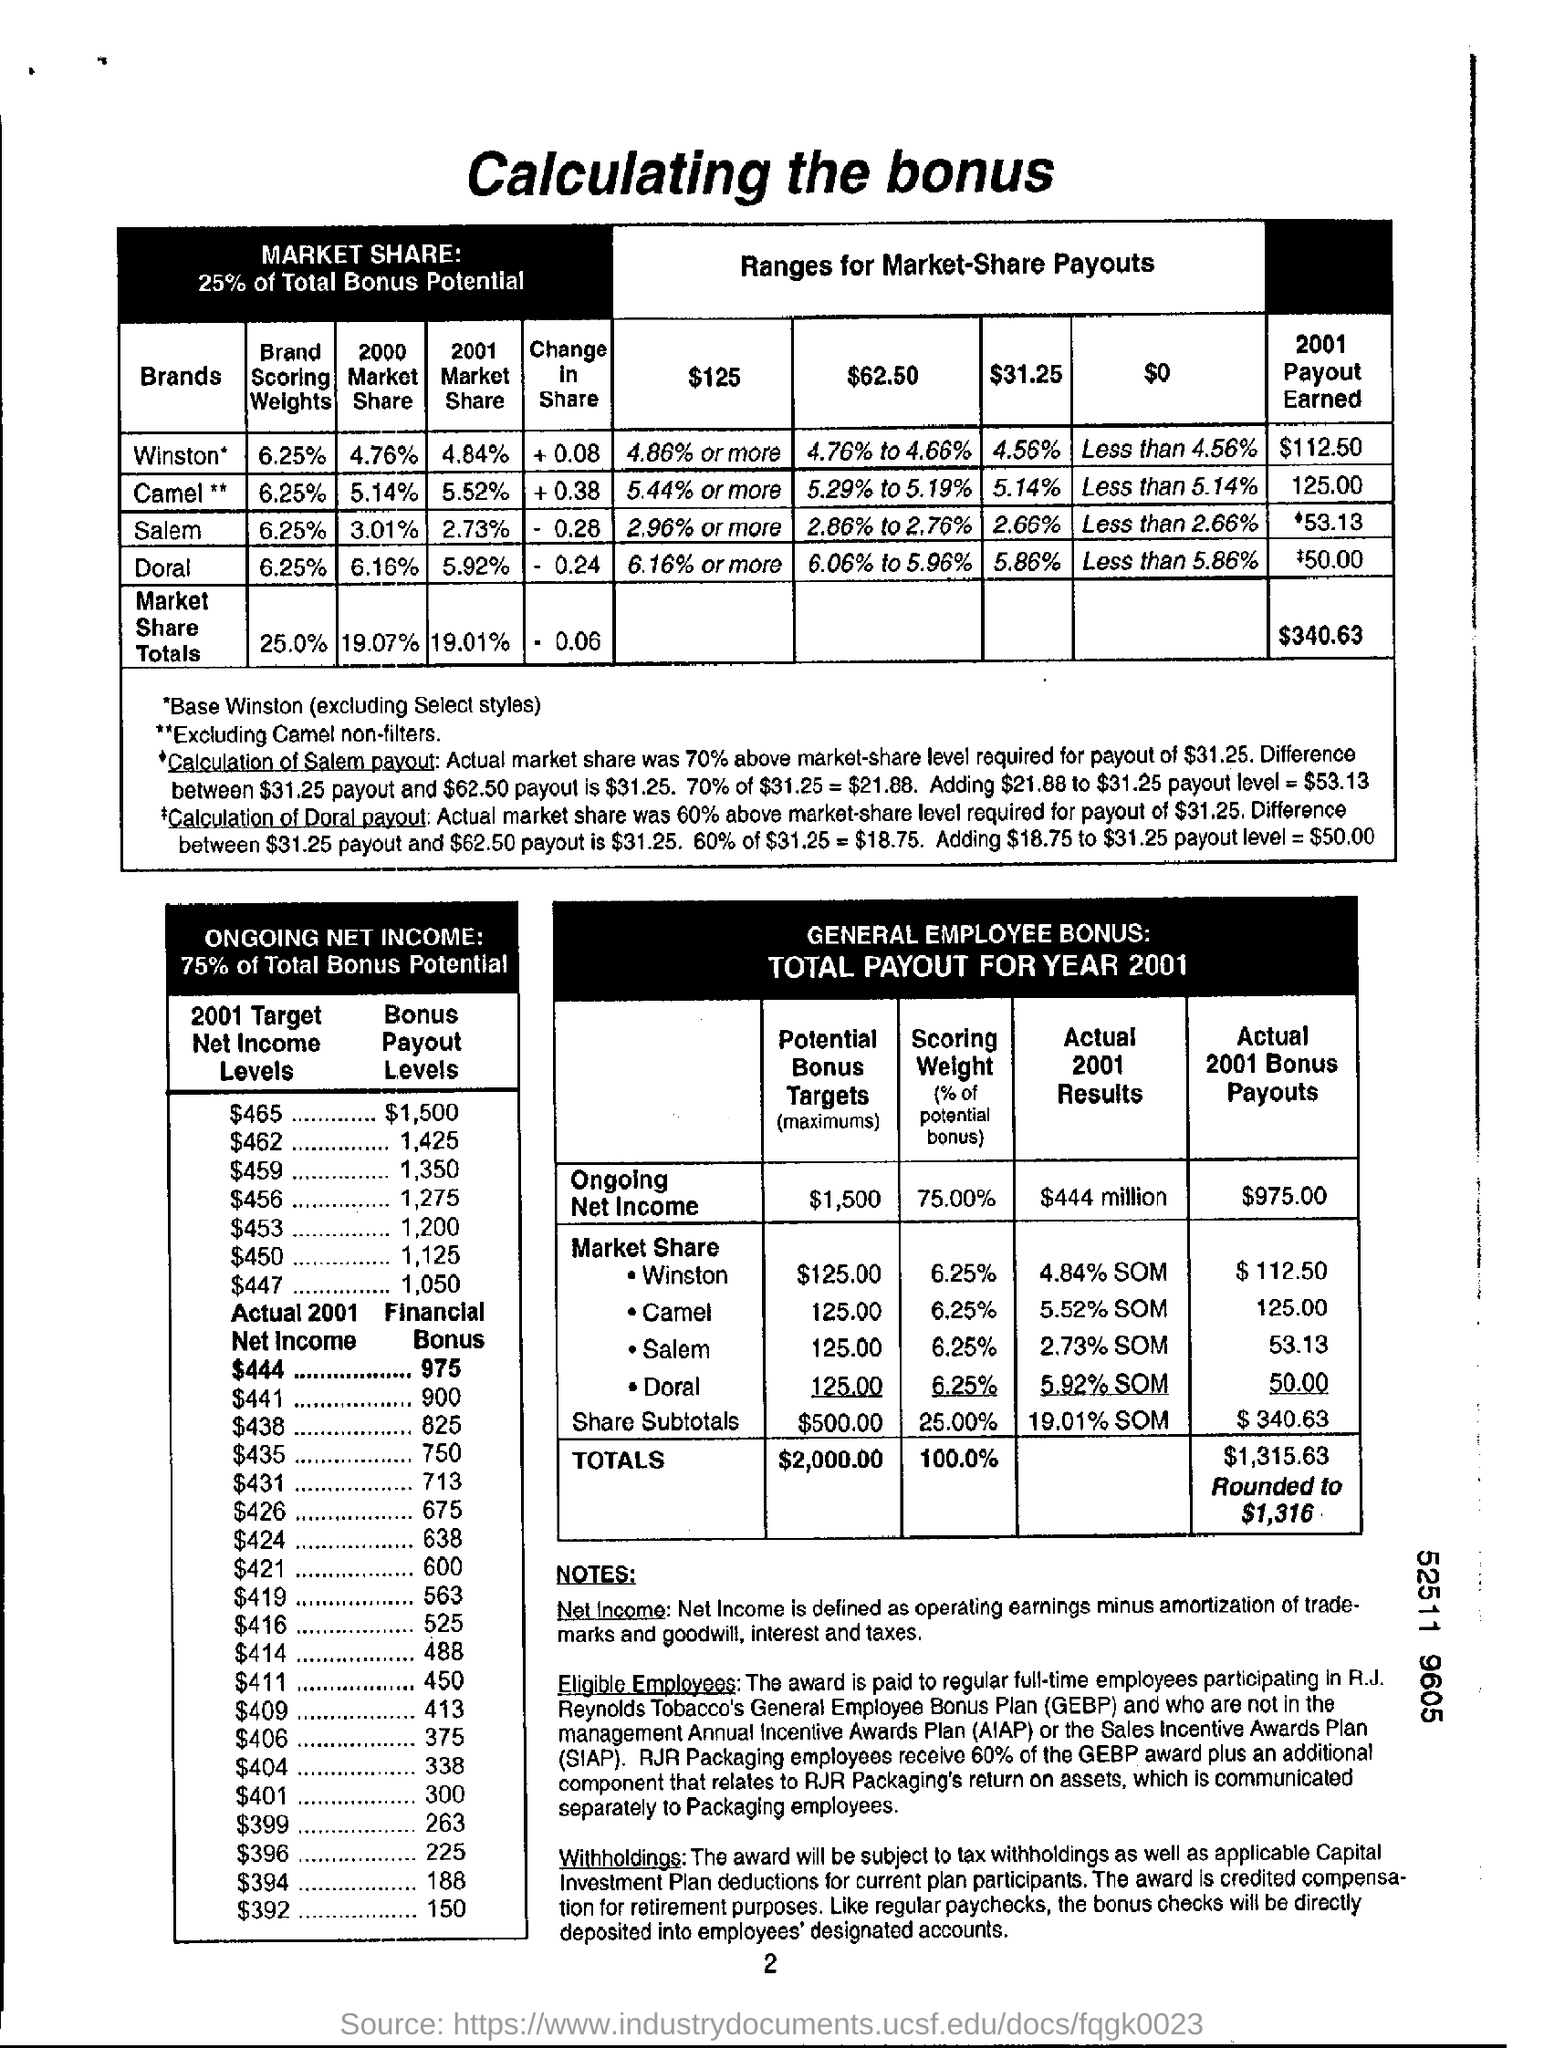What is the document heading ?
Give a very brief answer. Calculating the bonus. How much % of Total Bonus Potential is for MARKET SHARE?
Offer a terse response. 25%. How much is the Brand Scoring Weights for Brand "Winston*" based on table 1?
Provide a succinct answer. 6.25%. How much is '2001 Payout Earned' for brand ' Camel** ' based on table1 ?
Ensure brevity in your answer.  125.00. What is the total ' 2001 Payout Earned' based on table 1?
Keep it short and to the point. $340.63. How much is the ' 2001 Target Net Income Level' against the 'Bonus Payout Level' of $1,500 in table 2
Provide a succinct answer. $465. How much is the 'Ongoing Net Income' on Actual 2001 Results based on table 3-'General Employee Bonus' ?
Provide a short and direct response. $444 million. What is the 'Actual 2001 Bonus Payouts' for 'Winston' in Market Share according to table 3?
Ensure brevity in your answer.  $ 112.50. How much is the 'Financial Bonus' against 'Actual 2001 Net come' for $444 according to table 2 ?
Provide a short and direct response. 975. How much is the Total 'Potential Bonus Target' based on 'General Employee Bonus' table ?
Offer a terse response. $2,000.00. 